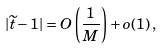<formula> <loc_0><loc_0><loc_500><loc_500>| \widetilde { t } - 1 | = O \left ( \frac { 1 } { M } \right ) + o ( 1 ) \, ,</formula> 